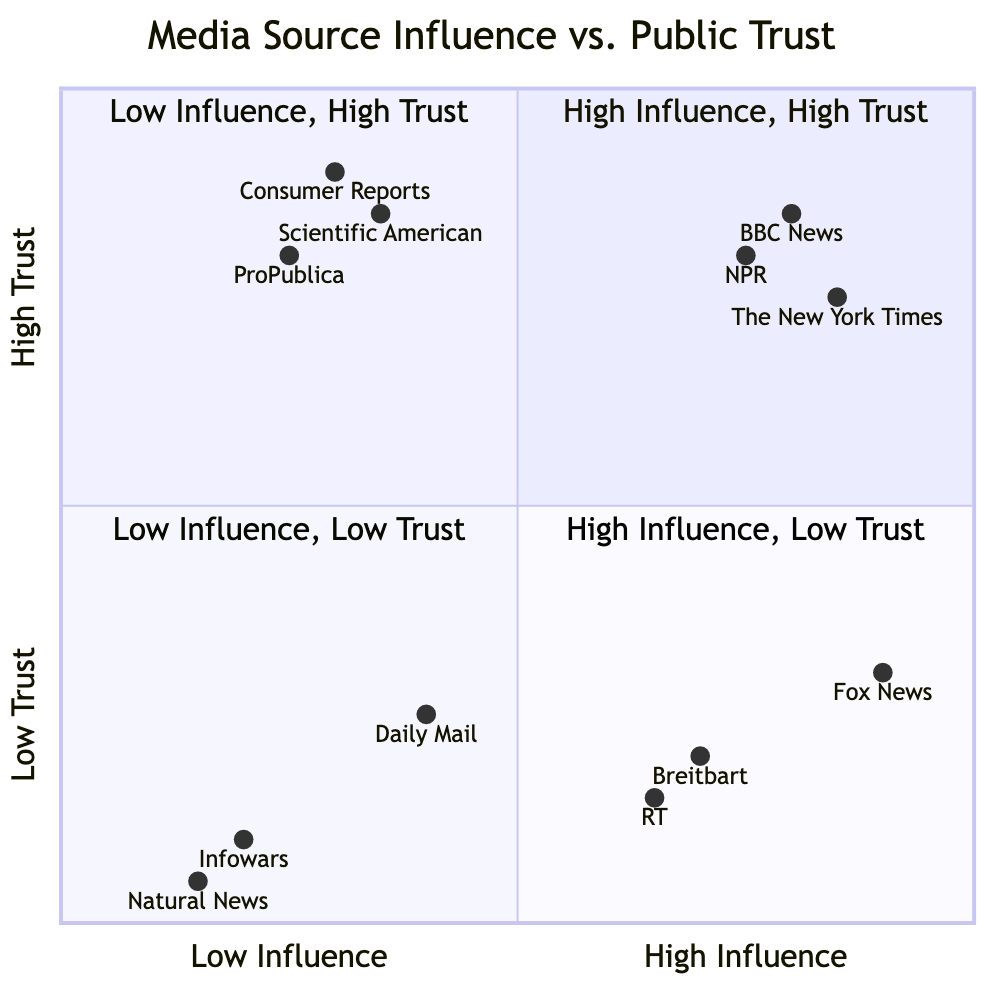What media sources are located in the High Influence, High Trust quadrant? The High Influence, High Trust quadrant contains media sources characterized by both significant influence and a high level of public trust. The examples provided in this quadrant are BBC News, NPR, and The New York Times.
Answer: BBC News, NPR, The New York Times Which media source is in the Low Influence, High Trust quadrant? To determine the media sources in the Low Influence, High Trust quadrant, we look at examples provided in that quadrant. They include Consumer Reports, Scientific American, and ProPublica, which all exhibit low influence but high trust.
Answer: Consumer Reports What is the trust level of Fox News? The diagram provides specific coordinates for Fox News, indicating its position in the Low Trust section. The y-coordinate is 0.3, which reflects its low level of public trust.
Answer: 0.3 How many media sources are categorized as Low Influence, Low Trust? The quadrant for Low Influence, Low Trust lists three media sources: Infowars, Daily Mail, and Natural News. Counting these examples reveals there are three sources in this quadrant.
Answer: 3 Which quadrant features media sources with both high influence and low trust? The quadrant that pertains to the combination of high influence and low trust is clearly marked as High Influence, Low Trust, specifically featuring media sources like Fox News, Breitbart, and RT.
Answer: High Influence, Low Trust What is the influence level of Scientific American? Scientific American is categorized in the Low Influence quadrant, specifically with a coordinate of 0.35 on the x-axis. Consequently, its influence level is identified as low.
Answer: 0.35 What is the highest trust level recorded among the media sources in the chart? The highest trust level among the listed media sources is 0.9, which corresponds to Consumer Reports located in the Low Influence, High Trust quadrant, confirming its high trustworthiness.
Answer: 0.9 Which source has the lowest influence and trust? Infowars holds the lowest positions in both influence and trust; its coordinates of (0.2, 0.1) place it firmly in the Low Influence, Low Trust quadrant.
Answer: Infowars 